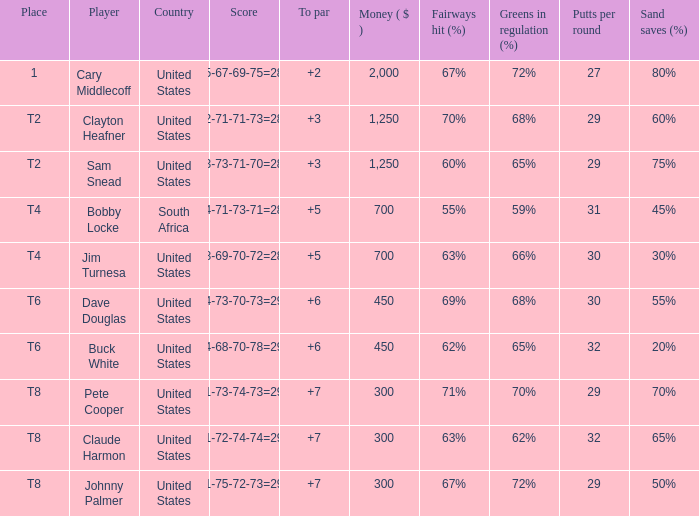Would you be able to parse every entry in this table? {'header': ['Place', 'Player', 'Country', 'Score', 'To par', 'Money ( $ )', 'Fairways hit (%)', 'Greens in regulation (%)', 'Putts per round', 'Sand saves (%)'], 'rows': [['1', 'Cary Middlecoff', 'United States', '75-67-69-75=286', '+2', '2,000', '67%', '72%', '27', '80%'], ['T2', 'Clayton Heafner', 'United States', '72-71-71-73=287', '+3', '1,250', '70%', '68%', '29', '60%'], ['T2', 'Sam Snead', 'United States', '73-73-71-70=287', '+3', '1,250', '60%', '65%', '29', '75%'], ['T4', 'Bobby Locke', 'South Africa', '74-71-73-71=289', '+5', '700', '55%', '59%', '31', '45%'], ['T4', 'Jim Turnesa', 'United States', '78-69-70-72=289', '+5', '700', '63%', '66%', '30', '30%'], ['T6', 'Dave Douglas', 'United States', '74-73-70-73=290', '+6', '450', '69%', '68%', '30', '55%'], ['T6', 'Buck White', 'United States', '74-68-70-78=290', '+6', '450', '62%', '65%', '32', '20%'], ['T8', 'Pete Cooper', 'United States', '71-73-74-73=291', '+7', '300', '71%', '70%', '29', '70%'], ['T8', 'Claude Harmon', 'United States', '71-72-74-74=291', '+7', '300', '63%', '62%', '32', '65%'], ['T8', 'Johnny Palmer', 'United States', '71-75-72-73=291', '+7', '300', '67%', '72%', '29', '50%']]} What Country is Player Sam Snead with a To par of less than 5 from? United States. 